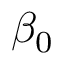<formula> <loc_0><loc_0><loc_500><loc_500>\beta _ { 0 }</formula> 